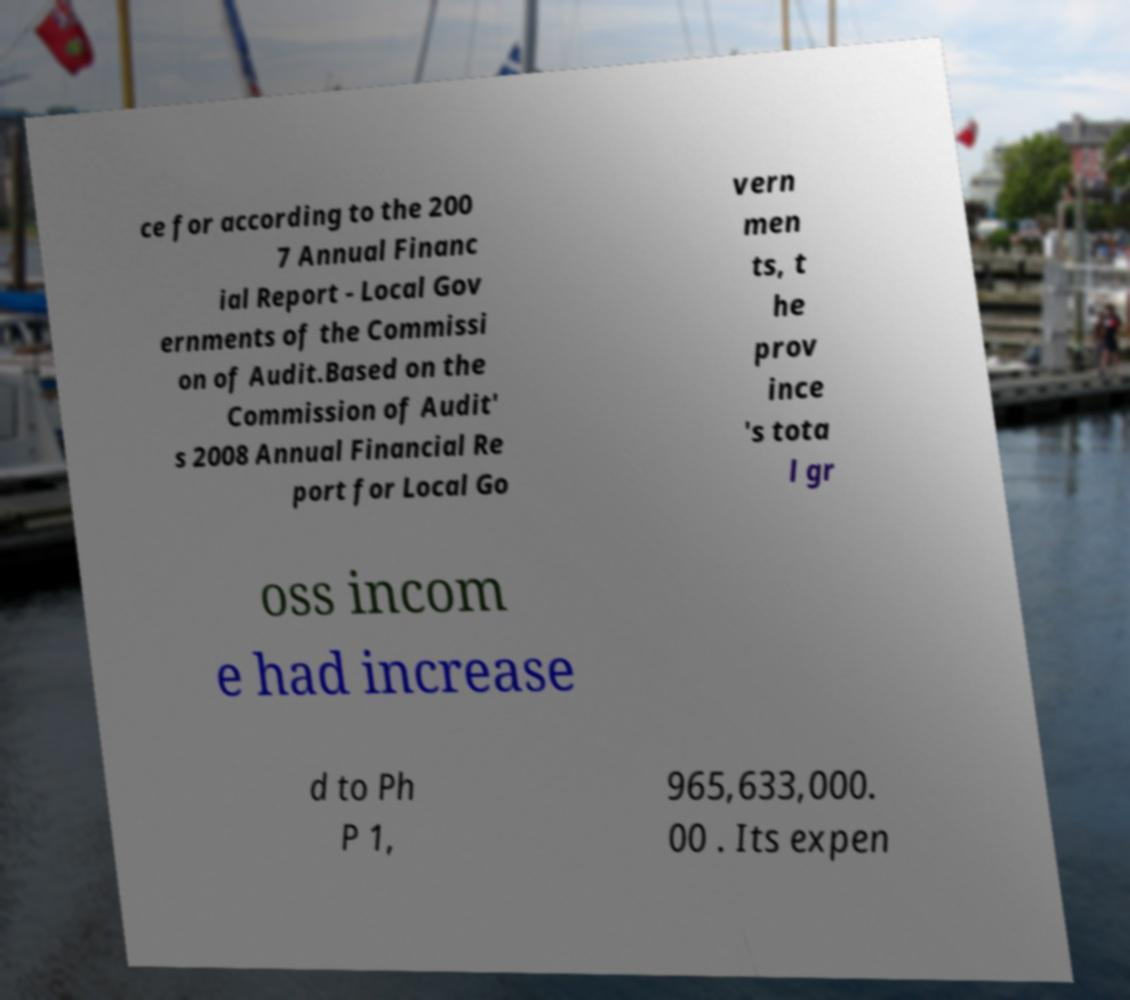Please read and relay the text visible in this image. What does it say? ce for according to the 200 7 Annual Financ ial Report - Local Gov ernments of the Commissi on of Audit.Based on the Commission of Audit' s 2008 Annual Financial Re port for Local Go vern men ts, t he prov ince 's tota l gr oss incom e had increase d to Ph P 1, 965,633,000. 00 . Its expen 